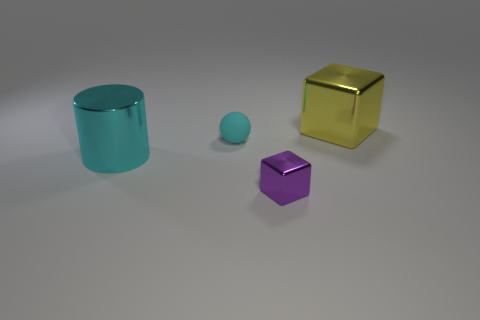Are there any small spheres of the same color as the big block?
Your response must be concise. No. What is the shape of the other shiny object that is the same size as the yellow metal object?
Provide a succinct answer. Cylinder. Is the number of green balls less than the number of yellow cubes?
Offer a very short reply. Yes. What number of metallic things are the same size as the cyan cylinder?
Give a very brief answer. 1. There is a thing that is the same color as the large cylinder; what is its shape?
Offer a very short reply. Sphere. What is the purple cube made of?
Your answer should be very brief. Metal. What size is the shiny cube that is right of the tiny metal block?
Keep it short and to the point. Large. What number of other yellow metal things are the same shape as the yellow metallic thing?
Offer a terse response. 0. What shape is the other big thing that is made of the same material as the yellow thing?
Offer a very short reply. Cylinder. What number of yellow things are either cubes or big metallic objects?
Offer a very short reply. 1. 